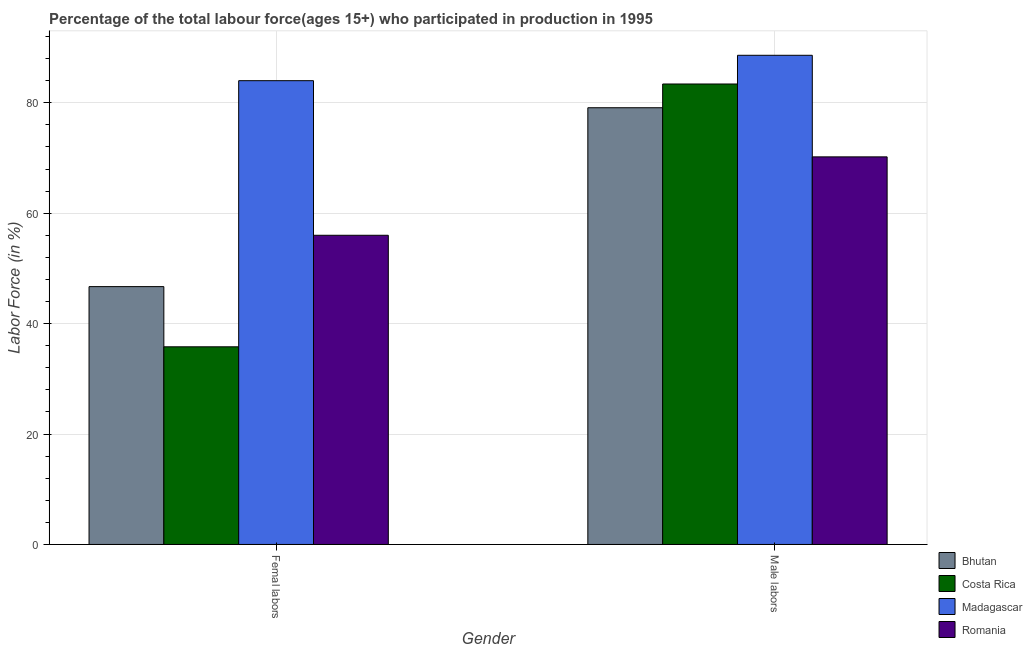How many different coloured bars are there?
Provide a succinct answer. 4. How many groups of bars are there?
Your answer should be very brief. 2. How many bars are there on the 1st tick from the left?
Your answer should be compact. 4. What is the label of the 1st group of bars from the left?
Your answer should be compact. Femal labors. What is the percentage of female labor force in Romania?
Make the answer very short. 56. Across all countries, what is the maximum percentage of male labour force?
Make the answer very short. 88.6. Across all countries, what is the minimum percentage of female labor force?
Your answer should be very brief. 35.8. In which country was the percentage of female labor force maximum?
Your answer should be very brief. Madagascar. What is the total percentage of female labor force in the graph?
Provide a short and direct response. 222.5. What is the difference between the percentage of male labour force in Romania and the percentage of female labor force in Costa Rica?
Give a very brief answer. 34.4. What is the average percentage of male labour force per country?
Make the answer very short. 80.32. What is the difference between the percentage of female labor force and percentage of male labour force in Romania?
Your answer should be very brief. -14.2. In how many countries, is the percentage of female labor force greater than 64 %?
Your answer should be very brief. 1. What is the ratio of the percentage of male labour force in Bhutan to that in Costa Rica?
Give a very brief answer. 0.95. Is the percentage of female labor force in Madagascar less than that in Bhutan?
Provide a short and direct response. No. How many bars are there?
Ensure brevity in your answer.  8. Are all the bars in the graph horizontal?
Offer a very short reply. No. How many countries are there in the graph?
Keep it short and to the point. 4. Are the values on the major ticks of Y-axis written in scientific E-notation?
Offer a very short reply. No. How are the legend labels stacked?
Make the answer very short. Vertical. What is the title of the graph?
Your answer should be compact. Percentage of the total labour force(ages 15+) who participated in production in 1995. What is the label or title of the X-axis?
Provide a succinct answer. Gender. What is the Labor Force (in %) of Bhutan in Femal labors?
Provide a succinct answer. 46.7. What is the Labor Force (in %) in Costa Rica in Femal labors?
Keep it short and to the point. 35.8. What is the Labor Force (in %) of Madagascar in Femal labors?
Your answer should be very brief. 84. What is the Labor Force (in %) in Romania in Femal labors?
Keep it short and to the point. 56. What is the Labor Force (in %) in Bhutan in Male labors?
Offer a terse response. 79.1. What is the Labor Force (in %) in Costa Rica in Male labors?
Your response must be concise. 83.4. What is the Labor Force (in %) in Madagascar in Male labors?
Your response must be concise. 88.6. What is the Labor Force (in %) of Romania in Male labors?
Keep it short and to the point. 70.2. Across all Gender, what is the maximum Labor Force (in %) of Bhutan?
Offer a terse response. 79.1. Across all Gender, what is the maximum Labor Force (in %) in Costa Rica?
Provide a short and direct response. 83.4. Across all Gender, what is the maximum Labor Force (in %) of Madagascar?
Offer a terse response. 88.6. Across all Gender, what is the maximum Labor Force (in %) of Romania?
Provide a succinct answer. 70.2. Across all Gender, what is the minimum Labor Force (in %) of Bhutan?
Your answer should be very brief. 46.7. Across all Gender, what is the minimum Labor Force (in %) of Costa Rica?
Offer a terse response. 35.8. Across all Gender, what is the minimum Labor Force (in %) of Madagascar?
Keep it short and to the point. 84. Across all Gender, what is the minimum Labor Force (in %) of Romania?
Offer a terse response. 56. What is the total Labor Force (in %) of Bhutan in the graph?
Provide a succinct answer. 125.8. What is the total Labor Force (in %) of Costa Rica in the graph?
Ensure brevity in your answer.  119.2. What is the total Labor Force (in %) in Madagascar in the graph?
Provide a succinct answer. 172.6. What is the total Labor Force (in %) in Romania in the graph?
Provide a succinct answer. 126.2. What is the difference between the Labor Force (in %) of Bhutan in Femal labors and that in Male labors?
Offer a very short reply. -32.4. What is the difference between the Labor Force (in %) of Costa Rica in Femal labors and that in Male labors?
Keep it short and to the point. -47.6. What is the difference between the Labor Force (in %) of Bhutan in Femal labors and the Labor Force (in %) of Costa Rica in Male labors?
Provide a succinct answer. -36.7. What is the difference between the Labor Force (in %) in Bhutan in Femal labors and the Labor Force (in %) in Madagascar in Male labors?
Your answer should be compact. -41.9. What is the difference between the Labor Force (in %) of Bhutan in Femal labors and the Labor Force (in %) of Romania in Male labors?
Offer a very short reply. -23.5. What is the difference between the Labor Force (in %) of Costa Rica in Femal labors and the Labor Force (in %) of Madagascar in Male labors?
Provide a short and direct response. -52.8. What is the difference between the Labor Force (in %) in Costa Rica in Femal labors and the Labor Force (in %) in Romania in Male labors?
Make the answer very short. -34.4. What is the average Labor Force (in %) in Bhutan per Gender?
Ensure brevity in your answer.  62.9. What is the average Labor Force (in %) of Costa Rica per Gender?
Give a very brief answer. 59.6. What is the average Labor Force (in %) of Madagascar per Gender?
Your answer should be compact. 86.3. What is the average Labor Force (in %) in Romania per Gender?
Provide a short and direct response. 63.1. What is the difference between the Labor Force (in %) in Bhutan and Labor Force (in %) in Madagascar in Femal labors?
Offer a terse response. -37.3. What is the difference between the Labor Force (in %) of Bhutan and Labor Force (in %) of Romania in Femal labors?
Make the answer very short. -9.3. What is the difference between the Labor Force (in %) of Costa Rica and Labor Force (in %) of Madagascar in Femal labors?
Ensure brevity in your answer.  -48.2. What is the difference between the Labor Force (in %) of Costa Rica and Labor Force (in %) of Romania in Femal labors?
Give a very brief answer. -20.2. What is the difference between the Labor Force (in %) in Madagascar and Labor Force (in %) in Romania in Femal labors?
Offer a very short reply. 28. What is the difference between the Labor Force (in %) in Bhutan and Labor Force (in %) in Madagascar in Male labors?
Provide a succinct answer. -9.5. What is the ratio of the Labor Force (in %) in Bhutan in Femal labors to that in Male labors?
Offer a terse response. 0.59. What is the ratio of the Labor Force (in %) in Costa Rica in Femal labors to that in Male labors?
Provide a succinct answer. 0.43. What is the ratio of the Labor Force (in %) of Madagascar in Femal labors to that in Male labors?
Offer a terse response. 0.95. What is the ratio of the Labor Force (in %) in Romania in Femal labors to that in Male labors?
Your answer should be compact. 0.8. What is the difference between the highest and the second highest Labor Force (in %) in Bhutan?
Your response must be concise. 32.4. What is the difference between the highest and the second highest Labor Force (in %) of Costa Rica?
Keep it short and to the point. 47.6. What is the difference between the highest and the lowest Labor Force (in %) in Bhutan?
Your response must be concise. 32.4. What is the difference between the highest and the lowest Labor Force (in %) of Costa Rica?
Provide a short and direct response. 47.6. What is the difference between the highest and the lowest Labor Force (in %) in Madagascar?
Provide a short and direct response. 4.6. 